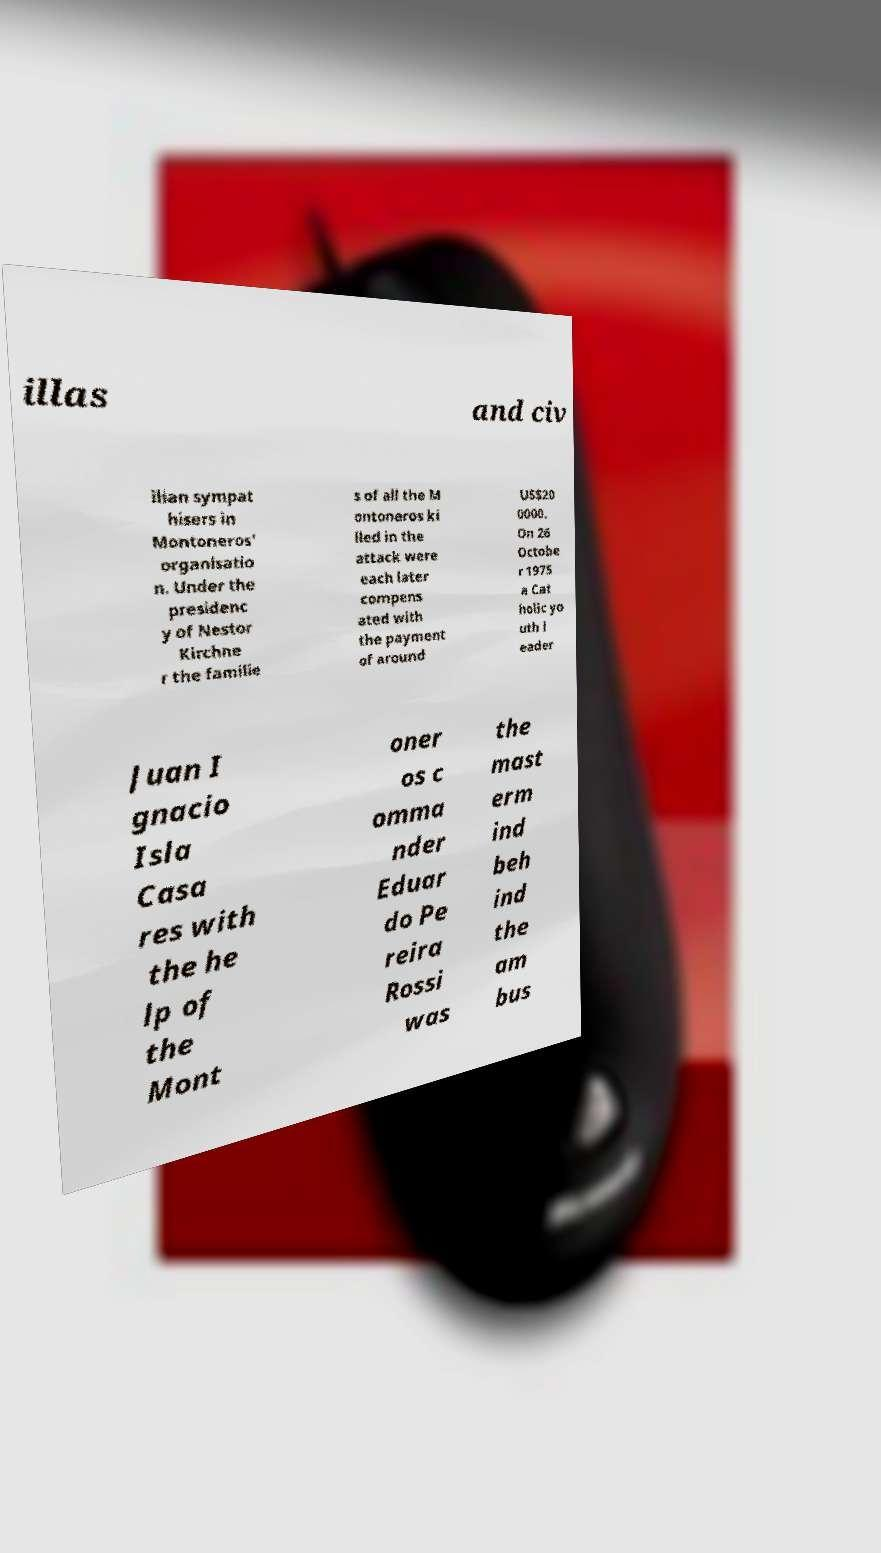There's text embedded in this image that I need extracted. Can you transcribe it verbatim? illas and civ ilian sympat hisers in Montoneros' organisatio n. Under the presidenc y of Nestor Kirchne r the familie s of all the M ontoneros ki lled in the attack were each later compens ated with the payment of around US$20 0000. On 26 Octobe r 1975 a Cat holic yo uth l eader Juan I gnacio Isla Casa res with the he lp of the Mont oner os c omma nder Eduar do Pe reira Rossi was the mast erm ind beh ind the am bus 